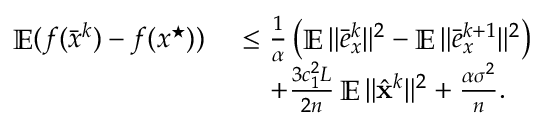Convert formula to latex. <formula><loc_0><loc_0><loc_500><loc_500>\begin{array} { r l } { \mathbb { E } ( f ( \bar { x } ^ { k } ) - f ( x ^ { ^ { * } } ) ) \ } & { \leq \frac { 1 } { \alpha } \left ( \mathbb { E } \| \bar { e } _ { x } ^ { k } \| ^ { 2 } - \mathbb { E } \| \bar { e } _ { x } ^ { k + 1 } \| ^ { 2 } \right ) } \\ & { \quad + \frac { 3 c _ { 1 } ^ { 2 } L } { 2 n } \mathbb { E } \| \hat { x } ^ { k } \| ^ { 2 } + \frac { \alpha \sigma ^ { 2 } } { n } . } \end{array}</formula> 